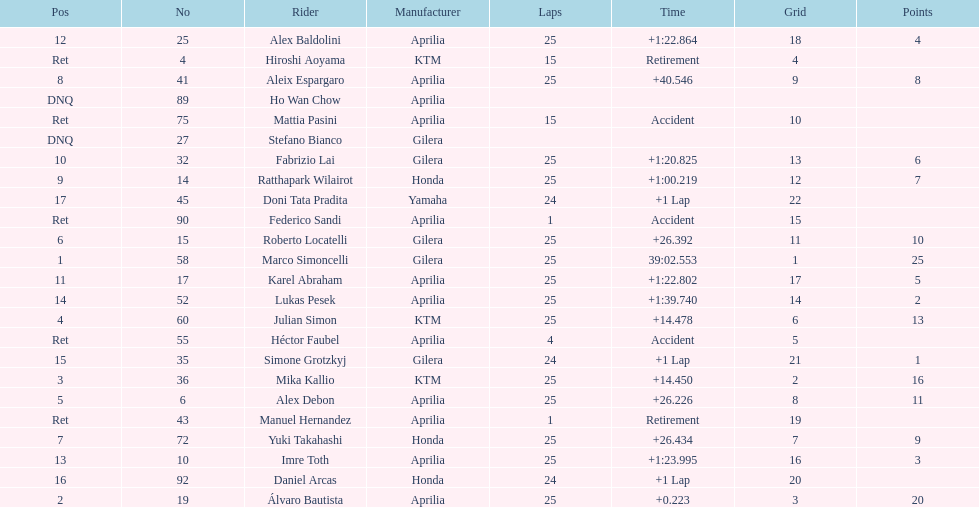The total amount of riders who did not qualify 2. 